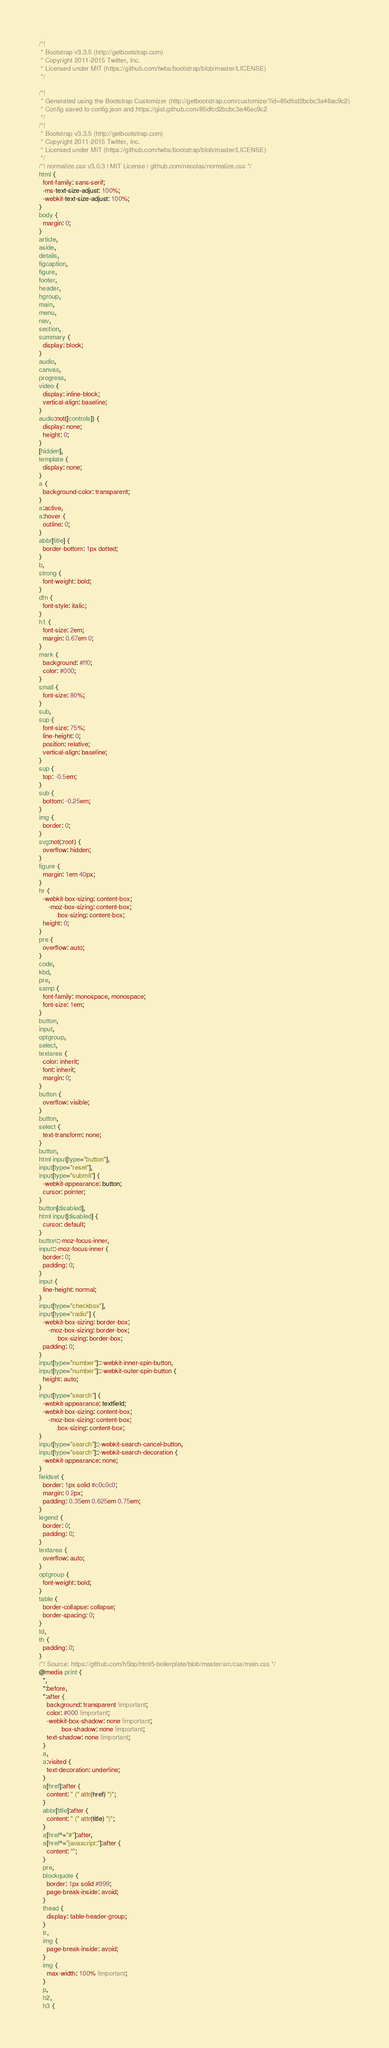Convert code to text. <code><loc_0><loc_0><loc_500><loc_500><_CSS_>/*!
 * Bootstrap v3.3.5 (http://getbootstrap.com)
 * Copyright 2011-2015 Twitter, Inc.
 * Licensed under MIT (https://github.com/twbs/bootstrap/blob/master/LICENSE)
 */

/*!
 * Generated using the Bootstrap Customizer (http://getbootstrap.com/customize/?id=85dfcd2bcbc3a46ac9c2)
 * Config saved to config.json and https://gist.github.com/85dfcd2bcbc3a46ac9c2
 */
/*!
 * Bootstrap v3.3.5 (http://getbootstrap.com)
 * Copyright 2011-2015 Twitter, Inc.
 * Licensed under MIT (https://github.com/twbs/bootstrap/blob/master/LICENSE)
 */
/*! normalize.css v3.0.3 | MIT License | github.com/necolas/normalize.css */
html {
  font-family: sans-serif;
  -ms-text-size-adjust: 100%;
  -webkit-text-size-adjust: 100%;
}
body {
  margin: 0;
}
article,
aside,
details,
figcaption,
figure,
footer,
header,
hgroup,
main,
menu,
nav,
section,
summary {
  display: block;
}
audio,
canvas,
progress,
video {
  display: inline-block;
  vertical-align: baseline;
}
audio:not([controls]) {
  display: none;
  height: 0;
}
[hidden],
template {
  display: none;
}
a {
  background-color: transparent;
}
a:active,
a:hover {
  outline: 0;
}
abbr[title] {
  border-bottom: 1px dotted;
}
b,
strong {
  font-weight: bold;
}
dfn {
  font-style: italic;
}
h1 {
  font-size: 2em;
  margin: 0.67em 0;
}
mark {
  background: #ff0;
  color: #000;
}
small {
  font-size: 80%;
}
sub,
sup {
  font-size: 75%;
  line-height: 0;
  position: relative;
  vertical-align: baseline;
}
sup {
  top: -0.5em;
}
sub {
  bottom: -0.25em;
}
img {
  border: 0;
}
svg:not(:root) {
  overflow: hidden;
}
figure {
  margin: 1em 40px;
}
hr {
  -webkit-box-sizing: content-box;
     -moz-box-sizing: content-box;
          box-sizing: content-box;
  height: 0;
}
pre {
  overflow: auto;
}
code,
kbd,
pre,
samp {
  font-family: monospace, monospace;
  font-size: 1em;
}
button,
input,
optgroup,
select,
textarea {
  color: inherit;
  font: inherit;
  margin: 0;
}
button {
  overflow: visible;
}
button,
select {
  text-transform: none;
}
button,
html input[type="button"],
input[type="reset"],
input[type="submit"] {
  -webkit-appearance: button;
  cursor: pointer;
}
button[disabled],
html input[disabled] {
  cursor: default;
}
button::-moz-focus-inner,
input::-moz-focus-inner {
  border: 0;
  padding: 0;
}
input {
  line-height: normal;
}
input[type="checkbox"],
input[type="radio"] {
  -webkit-box-sizing: border-box;
     -moz-box-sizing: border-box;
          box-sizing: border-box;
  padding: 0;
}
input[type="number"]::-webkit-inner-spin-button,
input[type="number"]::-webkit-outer-spin-button {
  height: auto;
}
input[type="search"] {
  -webkit-appearance: textfield;
  -webkit-box-sizing: content-box;
     -moz-box-sizing: content-box;
          box-sizing: content-box;
}
input[type="search"]::-webkit-search-cancel-button,
input[type="search"]::-webkit-search-decoration {
  -webkit-appearance: none;
}
fieldset {
  border: 1px solid #c0c0c0;
  margin: 0 2px;
  padding: 0.35em 0.625em 0.75em;
}
legend {
  border: 0;
  padding: 0;
}
textarea {
  overflow: auto;
}
optgroup {
  font-weight: bold;
}
table {
  border-collapse: collapse;
  border-spacing: 0;
}
td,
th {
  padding: 0;
}
/*! Source: https://github.com/h5bp/html5-boilerplate/blob/master/src/css/main.css */
@media print {
  *,
  *:before,
  *:after {
    background: transparent !important;
    color: #000 !important;
    -webkit-box-shadow: none !important;
            box-shadow: none !important;
    text-shadow: none !important;
  }
  a,
  a:visited {
    text-decoration: underline;
  }
  a[href]:after {
    content: " (" attr(href) ")";
  }
  abbr[title]:after {
    content: " (" attr(title) ")";
  }
  a[href^="#"]:after,
  a[href^="javascript:"]:after {
    content: "";
  }
  pre,
  blockquote {
    border: 1px solid #999;
    page-break-inside: avoid;
  }
  thead {
    display: table-header-group;
  }
  tr,
  img {
    page-break-inside: avoid;
  }
  img {
    max-width: 100% !important;
  }
  p,
  h2,
  h3 {</code> 